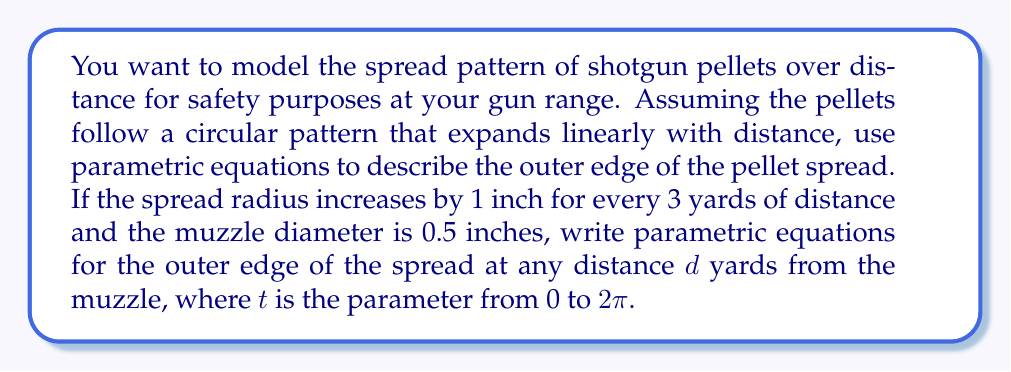Could you help me with this problem? To model the spread pattern of shotgun pellets, we need to consider how the radius of the circular spread changes with distance. Let's break this down step-by-step:

1) First, let's define the radius of the spread as a function of distance:
   - The spread increases by 1 inch for every 3 yards
   - The initial diameter (at the muzzle) is 0.5 inches, so the initial radius is 0.25 inches
   
   We can express this as: $r(d) = 0.25 + \frac{d}{3}$ (in inches)

2) Now, we need to create parametric equations for a circle with this radius:
   - The general parametric equations for a circle are:
     $x = r \cos(t)$
     $y = r \sin(t)$
   Where $r$ is the radius and $t$ is the parameter from 0 to $2\pi$

3) Substituting our radius function:
   $x(d,t) = (0.25 + \frac{d}{3}) \cos(t)$
   $y(d,t) = (0.25 + \frac{d}{3}) \sin(t)$

4) These equations give us the $(x,y)$ coordinates of the outer edge of the spread for any distance $d$ (in yards) and any angle $t$ (in radians).

5) To complete the model, we need a third equation for the distance:
   $z(d) = d$

Thus, our final parametric equations are:

$$\begin{cases}
x(d,t) = (0.25 + \frac{d}{3}) \cos(t) \\
y(d,t) = (0.25 + \frac{d}{3}) \sin(t) \\
z(d) = d
\end{cases}$$

Where $d$ is the distance in yards, $t$ is the parameter from 0 to $2\pi$, and $x$ and $y$ are in inches.
Answer: $$\begin{cases}
x(d,t) = (0.25 + \frac{d}{3}) \cos(t) \\
y(d,t) = (0.25 + \frac{d}{3}) \sin(t) \\
z(d) = d
\end{cases}$$
Where $d$ is in yards, $t$ is in radians (0 to $2\pi$), and $x$ and $y$ are in inches. 